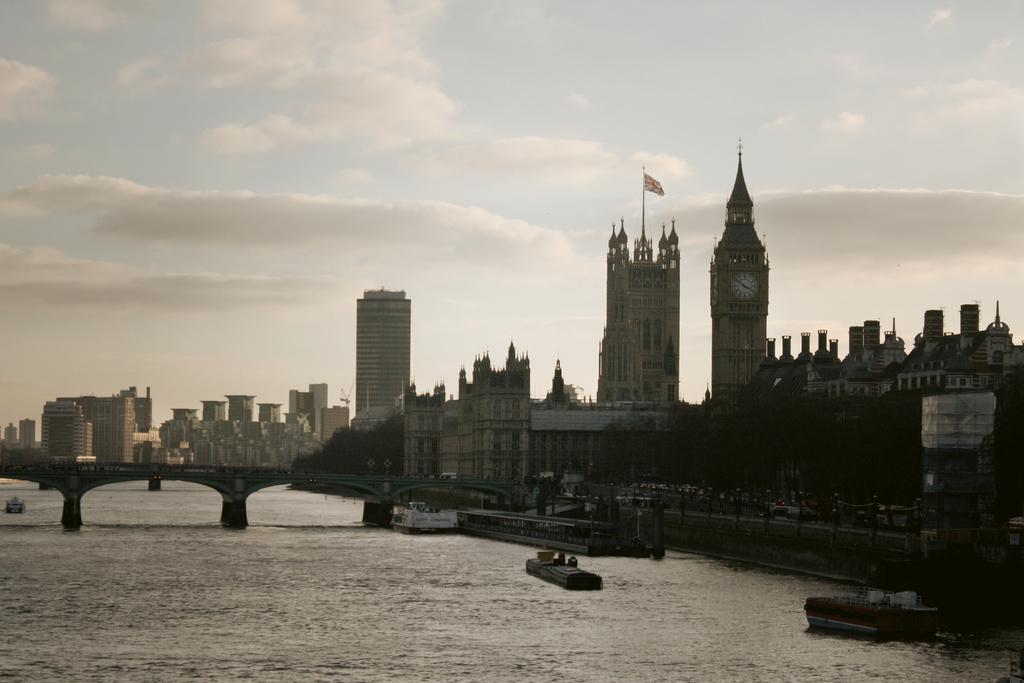In one or two sentences, can you explain what this image depicts? In the image in the center, we can see the sky, clouds, buildings, trees, water, one flag and one bridge. 